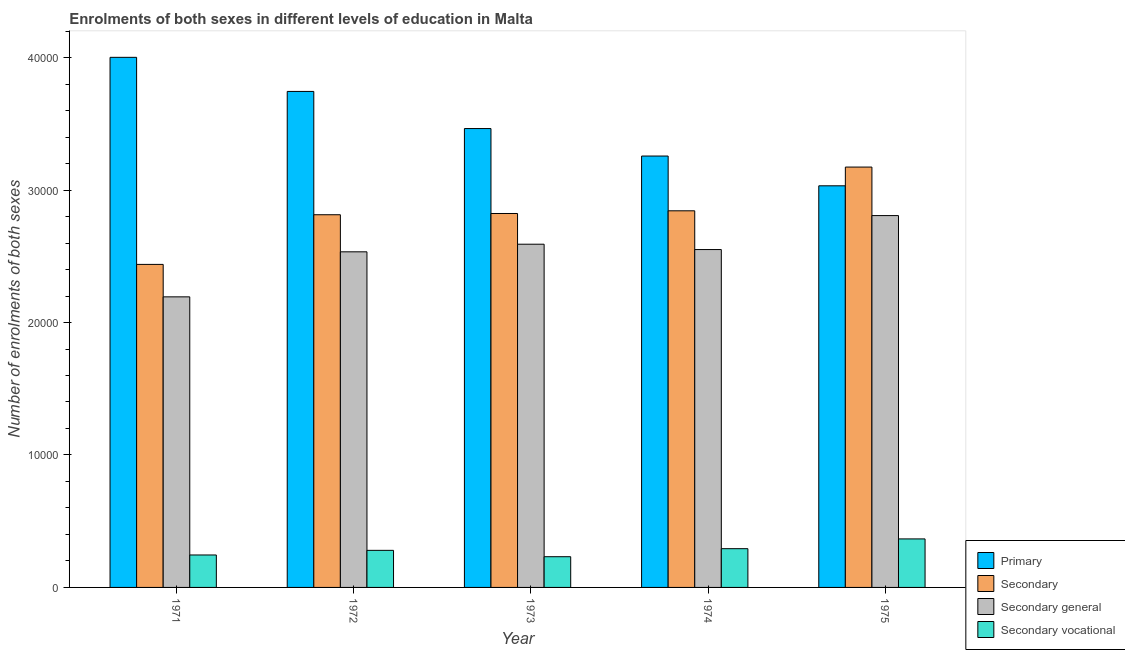How many different coloured bars are there?
Make the answer very short. 4. How many groups of bars are there?
Ensure brevity in your answer.  5. Are the number of bars on each tick of the X-axis equal?
Your answer should be compact. Yes. How many bars are there on the 4th tick from the left?
Provide a short and direct response. 4. What is the number of enrolments in primary education in 1973?
Ensure brevity in your answer.  3.46e+04. Across all years, what is the maximum number of enrolments in secondary vocational education?
Give a very brief answer. 3663. Across all years, what is the minimum number of enrolments in secondary general education?
Give a very brief answer. 2.19e+04. In which year was the number of enrolments in secondary general education maximum?
Keep it short and to the point. 1975. In which year was the number of enrolments in primary education minimum?
Ensure brevity in your answer.  1975. What is the total number of enrolments in secondary general education in the graph?
Ensure brevity in your answer.  1.27e+05. What is the difference between the number of enrolments in secondary general education in 1972 and that in 1974?
Provide a succinct answer. -171. What is the difference between the number of enrolments in secondary education in 1971 and the number of enrolments in primary education in 1973?
Offer a very short reply. -3843. What is the average number of enrolments in secondary vocational education per year?
Make the answer very short. 2831.2. What is the ratio of the number of enrolments in primary education in 1971 to that in 1974?
Provide a short and direct response. 1.23. Is the number of enrolments in secondary vocational education in 1971 less than that in 1974?
Provide a succinct answer. Yes. Is the difference between the number of enrolments in secondary education in 1974 and 1975 greater than the difference between the number of enrolments in secondary vocational education in 1974 and 1975?
Provide a succinct answer. No. What is the difference between the highest and the second highest number of enrolments in primary education?
Ensure brevity in your answer.  2574. What is the difference between the highest and the lowest number of enrolments in secondary vocational education?
Offer a very short reply. 1344. In how many years, is the number of enrolments in secondary vocational education greater than the average number of enrolments in secondary vocational education taken over all years?
Keep it short and to the point. 2. Is the sum of the number of enrolments in secondary vocational education in 1972 and 1975 greater than the maximum number of enrolments in primary education across all years?
Provide a succinct answer. Yes. Is it the case that in every year, the sum of the number of enrolments in secondary vocational education and number of enrolments in primary education is greater than the sum of number of enrolments in secondary education and number of enrolments in secondary general education?
Your response must be concise. No. What does the 3rd bar from the left in 1971 represents?
Give a very brief answer. Secondary general. What does the 2nd bar from the right in 1973 represents?
Give a very brief answer. Secondary general. Are all the bars in the graph horizontal?
Your answer should be compact. No. How many years are there in the graph?
Keep it short and to the point. 5. Are the values on the major ticks of Y-axis written in scientific E-notation?
Offer a very short reply. No. Does the graph contain any zero values?
Provide a short and direct response. No. Does the graph contain grids?
Provide a short and direct response. No. How many legend labels are there?
Your answer should be compact. 4. How are the legend labels stacked?
Provide a succinct answer. Vertical. What is the title of the graph?
Offer a terse response. Enrolments of both sexes in different levels of education in Malta. What is the label or title of the Y-axis?
Provide a succinct answer. Number of enrolments of both sexes. What is the Number of enrolments of both sexes of Primary in 1971?
Your answer should be compact. 4.00e+04. What is the Number of enrolments of both sexes of Secondary in 1971?
Your answer should be compact. 2.44e+04. What is the Number of enrolments of both sexes of Secondary general in 1971?
Your answer should be very brief. 2.19e+04. What is the Number of enrolments of both sexes in Secondary vocational in 1971?
Your answer should be compact. 2450. What is the Number of enrolments of both sexes of Primary in 1972?
Ensure brevity in your answer.  3.74e+04. What is the Number of enrolments of both sexes of Secondary in 1972?
Provide a short and direct response. 2.81e+04. What is the Number of enrolments of both sexes of Secondary general in 1972?
Your answer should be very brief. 2.53e+04. What is the Number of enrolments of both sexes of Secondary vocational in 1972?
Keep it short and to the point. 2799. What is the Number of enrolments of both sexes of Primary in 1973?
Ensure brevity in your answer.  3.46e+04. What is the Number of enrolments of both sexes of Secondary in 1973?
Your response must be concise. 2.82e+04. What is the Number of enrolments of both sexes of Secondary general in 1973?
Provide a succinct answer. 2.59e+04. What is the Number of enrolments of both sexes in Secondary vocational in 1973?
Provide a succinct answer. 2319. What is the Number of enrolments of both sexes of Primary in 1974?
Ensure brevity in your answer.  3.26e+04. What is the Number of enrolments of both sexes in Secondary in 1974?
Your answer should be compact. 2.84e+04. What is the Number of enrolments of both sexes of Secondary general in 1974?
Offer a very short reply. 2.55e+04. What is the Number of enrolments of both sexes in Secondary vocational in 1974?
Make the answer very short. 2925. What is the Number of enrolments of both sexes of Primary in 1975?
Provide a short and direct response. 3.03e+04. What is the Number of enrolments of both sexes in Secondary in 1975?
Your answer should be compact. 3.17e+04. What is the Number of enrolments of both sexes in Secondary general in 1975?
Keep it short and to the point. 2.81e+04. What is the Number of enrolments of both sexes in Secondary vocational in 1975?
Ensure brevity in your answer.  3663. Across all years, what is the maximum Number of enrolments of both sexes in Primary?
Keep it short and to the point. 4.00e+04. Across all years, what is the maximum Number of enrolments of both sexes of Secondary?
Provide a succinct answer. 3.17e+04. Across all years, what is the maximum Number of enrolments of both sexes in Secondary general?
Your response must be concise. 2.81e+04. Across all years, what is the maximum Number of enrolments of both sexes of Secondary vocational?
Make the answer very short. 3663. Across all years, what is the minimum Number of enrolments of both sexes in Primary?
Provide a short and direct response. 3.03e+04. Across all years, what is the minimum Number of enrolments of both sexes in Secondary?
Your answer should be very brief. 2.44e+04. Across all years, what is the minimum Number of enrolments of both sexes in Secondary general?
Ensure brevity in your answer.  2.19e+04. Across all years, what is the minimum Number of enrolments of both sexes in Secondary vocational?
Offer a terse response. 2319. What is the total Number of enrolments of both sexes of Primary in the graph?
Ensure brevity in your answer.  1.75e+05. What is the total Number of enrolments of both sexes in Secondary in the graph?
Your response must be concise. 1.41e+05. What is the total Number of enrolments of both sexes in Secondary general in the graph?
Make the answer very short. 1.27e+05. What is the total Number of enrolments of both sexes in Secondary vocational in the graph?
Offer a terse response. 1.42e+04. What is the difference between the Number of enrolments of both sexes of Primary in 1971 and that in 1972?
Offer a terse response. 2574. What is the difference between the Number of enrolments of both sexes of Secondary in 1971 and that in 1972?
Offer a very short reply. -3749. What is the difference between the Number of enrolments of both sexes in Secondary general in 1971 and that in 1972?
Give a very brief answer. -3400. What is the difference between the Number of enrolments of both sexes in Secondary vocational in 1971 and that in 1972?
Provide a short and direct response. -349. What is the difference between the Number of enrolments of both sexes of Primary in 1971 and that in 1973?
Keep it short and to the point. 5377. What is the difference between the Number of enrolments of both sexes in Secondary in 1971 and that in 1973?
Offer a very short reply. -3843. What is the difference between the Number of enrolments of both sexes in Secondary general in 1971 and that in 1973?
Keep it short and to the point. -3974. What is the difference between the Number of enrolments of both sexes of Secondary vocational in 1971 and that in 1973?
Offer a terse response. 131. What is the difference between the Number of enrolments of both sexes in Primary in 1971 and that in 1974?
Ensure brevity in your answer.  7452. What is the difference between the Number of enrolments of both sexes in Secondary in 1971 and that in 1974?
Ensure brevity in your answer.  -4046. What is the difference between the Number of enrolments of both sexes of Secondary general in 1971 and that in 1974?
Ensure brevity in your answer.  -3571. What is the difference between the Number of enrolments of both sexes of Secondary vocational in 1971 and that in 1974?
Your response must be concise. -475. What is the difference between the Number of enrolments of both sexes in Primary in 1971 and that in 1975?
Provide a short and direct response. 9699. What is the difference between the Number of enrolments of both sexes in Secondary in 1971 and that in 1975?
Ensure brevity in your answer.  -7348. What is the difference between the Number of enrolments of both sexes in Secondary general in 1971 and that in 1975?
Provide a succinct answer. -6135. What is the difference between the Number of enrolments of both sexes of Secondary vocational in 1971 and that in 1975?
Make the answer very short. -1213. What is the difference between the Number of enrolments of both sexes in Primary in 1972 and that in 1973?
Keep it short and to the point. 2803. What is the difference between the Number of enrolments of both sexes of Secondary in 1972 and that in 1973?
Make the answer very short. -94. What is the difference between the Number of enrolments of both sexes of Secondary general in 1972 and that in 1973?
Ensure brevity in your answer.  -574. What is the difference between the Number of enrolments of both sexes in Secondary vocational in 1972 and that in 1973?
Give a very brief answer. 480. What is the difference between the Number of enrolments of both sexes in Primary in 1972 and that in 1974?
Your answer should be compact. 4878. What is the difference between the Number of enrolments of both sexes in Secondary in 1972 and that in 1974?
Give a very brief answer. -297. What is the difference between the Number of enrolments of both sexes in Secondary general in 1972 and that in 1974?
Offer a terse response. -171. What is the difference between the Number of enrolments of both sexes of Secondary vocational in 1972 and that in 1974?
Your answer should be compact. -126. What is the difference between the Number of enrolments of both sexes in Primary in 1972 and that in 1975?
Provide a succinct answer. 7125. What is the difference between the Number of enrolments of both sexes of Secondary in 1972 and that in 1975?
Give a very brief answer. -3599. What is the difference between the Number of enrolments of both sexes of Secondary general in 1972 and that in 1975?
Your answer should be compact. -2735. What is the difference between the Number of enrolments of both sexes in Secondary vocational in 1972 and that in 1975?
Provide a short and direct response. -864. What is the difference between the Number of enrolments of both sexes of Primary in 1973 and that in 1974?
Ensure brevity in your answer.  2075. What is the difference between the Number of enrolments of both sexes in Secondary in 1973 and that in 1974?
Make the answer very short. -203. What is the difference between the Number of enrolments of both sexes in Secondary general in 1973 and that in 1974?
Your response must be concise. 403. What is the difference between the Number of enrolments of both sexes of Secondary vocational in 1973 and that in 1974?
Provide a succinct answer. -606. What is the difference between the Number of enrolments of both sexes of Primary in 1973 and that in 1975?
Your answer should be compact. 4322. What is the difference between the Number of enrolments of both sexes of Secondary in 1973 and that in 1975?
Provide a short and direct response. -3505. What is the difference between the Number of enrolments of both sexes of Secondary general in 1973 and that in 1975?
Your response must be concise. -2161. What is the difference between the Number of enrolments of both sexes in Secondary vocational in 1973 and that in 1975?
Offer a terse response. -1344. What is the difference between the Number of enrolments of both sexes in Primary in 1974 and that in 1975?
Offer a terse response. 2247. What is the difference between the Number of enrolments of both sexes in Secondary in 1974 and that in 1975?
Keep it short and to the point. -3302. What is the difference between the Number of enrolments of both sexes of Secondary general in 1974 and that in 1975?
Your response must be concise. -2564. What is the difference between the Number of enrolments of both sexes of Secondary vocational in 1974 and that in 1975?
Offer a terse response. -738. What is the difference between the Number of enrolments of both sexes of Primary in 1971 and the Number of enrolments of both sexes of Secondary in 1972?
Give a very brief answer. 1.19e+04. What is the difference between the Number of enrolments of both sexes in Primary in 1971 and the Number of enrolments of both sexes in Secondary general in 1972?
Your answer should be compact. 1.47e+04. What is the difference between the Number of enrolments of both sexes of Primary in 1971 and the Number of enrolments of both sexes of Secondary vocational in 1972?
Ensure brevity in your answer.  3.72e+04. What is the difference between the Number of enrolments of both sexes in Secondary in 1971 and the Number of enrolments of both sexes in Secondary general in 1972?
Make the answer very short. -950. What is the difference between the Number of enrolments of both sexes in Secondary in 1971 and the Number of enrolments of both sexes in Secondary vocational in 1972?
Offer a very short reply. 2.16e+04. What is the difference between the Number of enrolments of both sexes of Secondary general in 1971 and the Number of enrolments of both sexes of Secondary vocational in 1972?
Provide a succinct answer. 1.91e+04. What is the difference between the Number of enrolments of both sexes of Primary in 1971 and the Number of enrolments of both sexes of Secondary in 1973?
Give a very brief answer. 1.18e+04. What is the difference between the Number of enrolments of both sexes of Primary in 1971 and the Number of enrolments of both sexes of Secondary general in 1973?
Give a very brief answer. 1.41e+04. What is the difference between the Number of enrolments of both sexes of Primary in 1971 and the Number of enrolments of both sexes of Secondary vocational in 1973?
Ensure brevity in your answer.  3.77e+04. What is the difference between the Number of enrolments of both sexes of Secondary in 1971 and the Number of enrolments of both sexes of Secondary general in 1973?
Offer a very short reply. -1524. What is the difference between the Number of enrolments of both sexes in Secondary in 1971 and the Number of enrolments of both sexes in Secondary vocational in 1973?
Your response must be concise. 2.21e+04. What is the difference between the Number of enrolments of both sexes of Secondary general in 1971 and the Number of enrolments of both sexes of Secondary vocational in 1973?
Offer a terse response. 1.96e+04. What is the difference between the Number of enrolments of both sexes in Primary in 1971 and the Number of enrolments of both sexes in Secondary in 1974?
Ensure brevity in your answer.  1.16e+04. What is the difference between the Number of enrolments of both sexes in Primary in 1971 and the Number of enrolments of both sexes in Secondary general in 1974?
Give a very brief answer. 1.45e+04. What is the difference between the Number of enrolments of both sexes of Primary in 1971 and the Number of enrolments of both sexes of Secondary vocational in 1974?
Your answer should be compact. 3.71e+04. What is the difference between the Number of enrolments of both sexes of Secondary in 1971 and the Number of enrolments of both sexes of Secondary general in 1974?
Keep it short and to the point. -1121. What is the difference between the Number of enrolments of both sexes in Secondary in 1971 and the Number of enrolments of both sexes in Secondary vocational in 1974?
Keep it short and to the point. 2.15e+04. What is the difference between the Number of enrolments of both sexes of Secondary general in 1971 and the Number of enrolments of both sexes of Secondary vocational in 1974?
Provide a short and direct response. 1.90e+04. What is the difference between the Number of enrolments of both sexes of Primary in 1971 and the Number of enrolments of both sexes of Secondary in 1975?
Give a very brief answer. 8285. What is the difference between the Number of enrolments of both sexes in Primary in 1971 and the Number of enrolments of both sexes in Secondary general in 1975?
Provide a short and direct response. 1.19e+04. What is the difference between the Number of enrolments of both sexes of Primary in 1971 and the Number of enrolments of both sexes of Secondary vocational in 1975?
Ensure brevity in your answer.  3.64e+04. What is the difference between the Number of enrolments of both sexes in Secondary in 1971 and the Number of enrolments of both sexes in Secondary general in 1975?
Your response must be concise. -3685. What is the difference between the Number of enrolments of both sexes in Secondary in 1971 and the Number of enrolments of both sexes in Secondary vocational in 1975?
Your response must be concise. 2.07e+04. What is the difference between the Number of enrolments of both sexes of Secondary general in 1971 and the Number of enrolments of both sexes of Secondary vocational in 1975?
Provide a short and direct response. 1.83e+04. What is the difference between the Number of enrolments of both sexes of Primary in 1972 and the Number of enrolments of both sexes of Secondary in 1973?
Offer a terse response. 9216. What is the difference between the Number of enrolments of both sexes of Primary in 1972 and the Number of enrolments of both sexes of Secondary general in 1973?
Provide a short and direct response. 1.15e+04. What is the difference between the Number of enrolments of both sexes in Primary in 1972 and the Number of enrolments of both sexes in Secondary vocational in 1973?
Give a very brief answer. 3.51e+04. What is the difference between the Number of enrolments of both sexes in Secondary in 1972 and the Number of enrolments of both sexes in Secondary general in 1973?
Make the answer very short. 2225. What is the difference between the Number of enrolments of both sexes of Secondary in 1972 and the Number of enrolments of both sexes of Secondary vocational in 1973?
Your answer should be compact. 2.58e+04. What is the difference between the Number of enrolments of both sexes in Secondary general in 1972 and the Number of enrolments of both sexes in Secondary vocational in 1973?
Ensure brevity in your answer.  2.30e+04. What is the difference between the Number of enrolments of both sexes of Primary in 1972 and the Number of enrolments of both sexes of Secondary in 1974?
Offer a terse response. 9013. What is the difference between the Number of enrolments of both sexes of Primary in 1972 and the Number of enrolments of both sexes of Secondary general in 1974?
Keep it short and to the point. 1.19e+04. What is the difference between the Number of enrolments of both sexes in Primary in 1972 and the Number of enrolments of both sexes in Secondary vocational in 1974?
Provide a short and direct response. 3.45e+04. What is the difference between the Number of enrolments of both sexes in Secondary in 1972 and the Number of enrolments of both sexes in Secondary general in 1974?
Keep it short and to the point. 2628. What is the difference between the Number of enrolments of both sexes of Secondary in 1972 and the Number of enrolments of both sexes of Secondary vocational in 1974?
Keep it short and to the point. 2.52e+04. What is the difference between the Number of enrolments of both sexes in Secondary general in 1972 and the Number of enrolments of both sexes in Secondary vocational in 1974?
Your response must be concise. 2.24e+04. What is the difference between the Number of enrolments of both sexes in Primary in 1972 and the Number of enrolments of both sexes in Secondary in 1975?
Your response must be concise. 5711. What is the difference between the Number of enrolments of both sexes in Primary in 1972 and the Number of enrolments of both sexes in Secondary general in 1975?
Your answer should be very brief. 9374. What is the difference between the Number of enrolments of both sexes of Primary in 1972 and the Number of enrolments of both sexes of Secondary vocational in 1975?
Your response must be concise. 3.38e+04. What is the difference between the Number of enrolments of both sexes in Secondary in 1972 and the Number of enrolments of both sexes in Secondary general in 1975?
Provide a succinct answer. 64. What is the difference between the Number of enrolments of both sexes in Secondary in 1972 and the Number of enrolments of both sexes in Secondary vocational in 1975?
Offer a very short reply. 2.45e+04. What is the difference between the Number of enrolments of both sexes of Secondary general in 1972 and the Number of enrolments of both sexes of Secondary vocational in 1975?
Keep it short and to the point. 2.17e+04. What is the difference between the Number of enrolments of both sexes in Primary in 1973 and the Number of enrolments of both sexes in Secondary in 1974?
Provide a short and direct response. 6210. What is the difference between the Number of enrolments of both sexes in Primary in 1973 and the Number of enrolments of both sexes in Secondary general in 1974?
Ensure brevity in your answer.  9135. What is the difference between the Number of enrolments of both sexes of Primary in 1973 and the Number of enrolments of both sexes of Secondary vocational in 1974?
Keep it short and to the point. 3.17e+04. What is the difference between the Number of enrolments of both sexes of Secondary in 1973 and the Number of enrolments of both sexes of Secondary general in 1974?
Keep it short and to the point. 2722. What is the difference between the Number of enrolments of both sexes of Secondary in 1973 and the Number of enrolments of both sexes of Secondary vocational in 1974?
Give a very brief answer. 2.53e+04. What is the difference between the Number of enrolments of both sexes in Secondary general in 1973 and the Number of enrolments of both sexes in Secondary vocational in 1974?
Make the answer very short. 2.30e+04. What is the difference between the Number of enrolments of both sexes of Primary in 1973 and the Number of enrolments of both sexes of Secondary in 1975?
Your answer should be very brief. 2908. What is the difference between the Number of enrolments of both sexes in Primary in 1973 and the Number of enrolments of both sexes in Secondary general in 1975?
Give a very brief answer. 6571. What is the difference between the Number of enrolments of both sexes of Primary in 1973 and the Number of enrolments of both sexes of Secondary vocational in 1975?
Offer a very short reply. 3.10e+04. What is the difference between the Number of enrolments of both sexes of Secondary in 1973 and the Number of enrolments of both sexes of Secondary general in 1975?
Ensure brevity in your answer.  158. What is the difference between the Number of enrolments of both sexes of Secondary in 1973 and the Number of enrolments of both sexes of Secondary vocational in 1975?
Your answer should be compact. 2.46e+04. What is the difference between the Number of enrolments of both sexes in Secondary general in 1973 and the Number of enrolments of both sexes in Secondary vocational in 1975?
Provide a short and direct response. 2.22e+04. What is the difference between the Number of enrolments of both sexes of Primary in 1974 and the Number of enrolments of both sexes of Secondary in 1975?
Make the answer very short. 833. What is the difference between the Number of enrolments of both sexes in Primary in 1974 and the Number of enrolments of both sexes in Secondary general in 1975?
Keep it short and to the point. 4496. What is the difference between the Number of enrolments of both sexes of Primary in 1974 and the Number of enrolments of both sexes of Secondary vocational in 1975?
Your answer should be very brief. 2.89e+04. What is the difference between the Number of enrolments of both sexes in Secondary in 1974 and the Number of enrolments of both sexes in Secondary general in 1975?
Give a very brief answer. 361. What is the difference between the Number of enrolments of both sexes of Secondary in 1974 and the Number of enrolments of both sexes of Secondary vocational in 1975?
Offer a very short reply. 2.48e+04. What is the difference between the Number of enrolments of both sexes in Secondary general in 1974 and the Number of enrolments of both sexes in Secondary vocational in 1975?
Keep it short and to the point. 2.18e+04. What is the average Number of enrolments of both sexes in Primary per year?
Provide a succinct answer. 3.50e+04. What is the average Number of enrolments of both sexes in Secondary per year?
Provide a succinct answer. 2.82e+04. What is the average Number of enrolments of both sexes in Secondary general per year?
Your response must be concise. 2.54e+04. What is the average Number of enrolments of both sexes in Secondary vocational per year?
Offer a very short reply. 2831.2. In the year 1971, what is the difference between the Number of enrolments of both sexes of Primary and Number of enrolments of both sexes of Secondary?
Ensure brevity in your answer.  1.56e+04. In the year 1971, what is the difference between the Number of enrolments of both sexes in Primary and Number of enrolments of both sexes in Secondary general?
Provide a short and direct response. 1.81e+04. In the year 1971, what is the difference between the Number of enrolments of both sexes of Primary and Number of enrolments of both sexes of Secondary vocational?
Keep it short and to the point. 3.76e+04. In the year 1971, what is the difference between the Number of enrolments of both sexes of Secondary and Number of enrolments of both sexes of Secondary general?
Your answer should be compact. 2450. In the year 1971, what is the difference between the Number of enrolments of both sexes in Secondary and Number of enrolments of both sexes in Secondary vocational?
Offer a terse response. 2.19e+04. In the year 1971, what is the difference between the Number of enrolments of both sexes in Secondary general and Number of enrolments of both sexes in Secondary vocational?
Provide a succinct answer. 1.95e+04. In the year 1972, what is the difference between the Number of enrolments of both sexes of Primary and Number of enrolments of both sexes of Secondary?
Your response must be concise. 9310. In the year 1972, what is the difference between the Number of enrolments of both sexes of Primary and Number of enrolments of both sexes of Secondary general?
Your response must be concise. 1.21e+04. In the year 1972, what is the difference between the Number of enrolments of both sexes of Primary and Number of enrolments of both sexes of Secondary vocational?
Keep it short and to the point. 3.46e+04. In the year 1972, what is the difference between the Number of enrolments of both sexes of Secondary and Number of enrolments of both sexes of Secondary general?
Your answer should be very brief. 2799. In the year 1972, what is the difference between the Number of enrolments of both sexes of Secondary and Number of enrolments of both sexes of Secondary vocational?
Provide a short and direct response. 2.53e+04. In the year 1972, what is the difference between the Number of enrolments of both sexes in Secondary general and Number of enrolments of both sexes in Secondary vocational?
Offer a very short reply. 2.25e+04. In the year 1973, what is the difference between the Number of enrolments of both sexes of Primary and Number of enrolments of both sexes of Secondary?
Provide a short and direct response. 6413. In the year 1973, what is the difference between the Number of enrolments of both sexes of Primary and Number of enrolments of both sexes of Secondary general?
Your response must be concise. 8732. In the year 1973, what is the difference between the Number of enrolments of both sexes of Primary and Number of enrolments of both sexes of Secondary vocational?
Make the answer very short. 3.23e+04. In the year 1973, what is the difference between the Number of enrolments of both sexes in Secondary and Number of enrolments of both sexes in Secondary general?
Offer a very short reply. 2319. In the year 1973, what is the difference between the Number of enrolments of both sexes of Secondary and Number of enrolments of both sexes of Secondary vocational?
Keep it short and to the point. 2.59e+04. In the year 1973, what is the difference between the Number of enrolments of both sexes of Secondary general and Number of enrolments of both sexes of Secondary vocational?
Ensure brevity in your answer.  2.36e+04. In the year 1974, what is the difference between the Number of enrolments of both sexes in Primary and Number of enrolments of both sexes in Secondary?
Provide a succinct answer. 4135. In the year 1974, what is the difference between the Number of enrolments of both sexes in Primary and Number of enrolments of both sexes in Secondary general?
Ensure brevity in your answer.  7060. In the year 1974, what is the difference between the Number of enrolments of both sexes in Primary and Number of enrolments of both sexes in Secondary vocational?
Your response must be concise. 2.96e+04. In the year 1974, what is the difference between the Number of enrolments of both sexes in Secondary and Number of enrolments of both sexes in Secondary general?
Ensure brevity in your answer.  2925. In the year 1974, what is the difference between the Number of enrolments of both sexes in Secondary and Number of enrolments of both sexes in Secondary vocational?
Offer a very short reply. 2.55e+04. In the year 1974, what is the difference between the Number of enrolments of both sexes in Secondary general and Number of enrolments of both sexes in Secondary vocational?
Your answer should be very brief. 2.26e+04. In the year 1975, what is the difference between the Number of enrolments of both sexes in Primary and Number of enrolments of both sexes in Secondary?
Provide a short and direct response. -1414. In the year 1975, what is the difference between the Number of enrolments of both sexes of Primary and Number of enrolments of both sexes of Secondary general?
Ensure brevity in your answer.  2249. In the year 1975, what is the difference between the Number of enrolments of both sexes of Primary and Number of enrolments of both sexes of Secondary vocational?
Offer a terse response. 2.67e+04. In the year 1975, what is the difference between the Number of enrolments of both sexes in Secondary and Number of enrolments of both sexes in Secondary general?
Offer a very short reply. 3663. In the year 1975, what is the difference between the Number of enrolments of both sexes in Secondary and Number of enrolments of both sexes in Secondary vocational?
Offer a very short reply. 2.81e+04. In the year 1975, what is the difference between the Number of enrolments of both sexes of Secondary general and Number of enrolments of both sexes of Secondary vocational?
Provide a short and direct response. 2.44e+04. What is the ratio of the Number of enrolments of both sexes of Primary in 1971 to that in 1972?
Your answer should be compact. 1.07. What is the ratio of the Number of enrolments of both sexes of Secondary in 1971 to that in 1972?
Offer a terse response. 0.87. What is the ratio of the Number of enrolments of both sexes of Secondary general in 1971 to that in 1972?
Offer a very short reply. 0.87. What is the ratio of the Number of enrolments of both sexes of Secondary vocational in 1971 to that in 1972?
Offer a terse response. 0.88. What is the ratio of the Number of enrolments of both sexes in Primary in 1971 to that in 1973?
Your response must be concise. 1.16. What is the ratio of the Number of enrolments of both sexes in Secondary in 1971 to that in 1973?
Make the answer very short. 0.86. What is the ratio of the Number of enrolments of both sexes in Secondary general in 1971 to that in 1973?
Offer a very short reply. 0.85. What is the ratio of the Number of enrolments of both sexes of Secondary vocational in 1971 to that in 1973?
Ensure brevity in your answer.  1.06. What is the ratio of the Number of enrolments of both sexes in Primary in 1971 to that in 1974?
Make the answer very short. 1.23. What is the ratio of the Number of enrolments of both sexes of Secondary in 1971 to that in 1974?
Offer a very short reply. 0.86. What is the ratio of the Number of enrolments of both sexes of Secondary general in 1971 to that in 1974?
Offer a very short reply. 0.86. What is the ratio of the Number of enrolments of both sexes in Secondary vocational in 1971 to that in 1974?
Your answer should be compact. 0.84. What is the ratio of the Number of enrolments of both sexes of Primary in 1971 to that in 1975?
Ensure brevity in your answer.  1.32. What is the ratio of the Number of enrolments of both sexes in Secondary in 1971 to that in 1975?
Keep it short and to the point. 0.77. What is the ratio of the Number of enrolments of both sexes of Secondary general in 1971 to that in 1975?
Offer a terse response. 0.78. What is the ratio of the Number of enrolments of both sexes of Secondary vocational in 1971 to that in 1975?
Your answer should be very brief. 0.67. What is the ratio of the Number of enrolments of both sexes in Primary in 1972 to that in 1973?
Make the answer very short. 1.08. What is the ratio of the Number of enrolments of both sexes of Secondary in 1972 to that in 1973?
Your response must be concise. 1. What is the ratio of the Number of enrolments of both sexes in Secondary general in 1972 to that in 1973?
Ensure brevity in your answer.  0.98. What is the ratio of the Number of enrolments of both sexes in Secondary vocational in 1972 to that in 1973?
Your answer should be very brief. 1.21. What is the ratio of the Number of enrolments of both sexes in Primary in 1972 to that in 1974?
Offer a terse response. 1.15. What is the ratio of the Number of enrolments of both sexes of Secondary general in 1972 to that in 1974?
Provide a succinct answer. 0.99. What is the ratio of the Number of enrolments of both sexes in Secondary vocational in 1972 to that in 1974?
Give a very brief answer. 0.96. What is the ratio of the Number of enrolments of both sexes of Primary in 1972 to that in 1975?
Make the answer very short. 1.24. What is the ratio of the Number of enrolments of both sexes of Secondary in 1972 to that in 1975?
Ensure brevity in your answer.  0.89. What is the ratio of the Number of enrolments of both sexes of Secondary general in 1972 to that in 1975?
Offer a terse response. 0.9. What is the ratio of the Number of enrolments of both sexes of Secondary vocational in 1972 to that in 1975?
Make the answer very short. 0.76. What is the ratio of the Number of enrolments of both sexes in Primary in 1973 to that in 1974?
Give a very brief answer. 1.06. What is the ratio of the Number of enrolments of both sexes of Secondary in 1973 to that in 1974?
Offer a very short reply. 0.99. What is the ratio of the Number of enrolments of both sexes of Secondary general in 1973 to that in 1974?
Keep it short and to the point. 1.02. What is the ratio of the Number of enrolments of both sexes of Secondary vocational in 1973 to that in 1974?
Offer a very short reply. 0.79. What is the ratio of the Number of enrolments of both sexes in Primary in 1973 to that in 1975?
Ensure brevity in your answer.  1.14. What is the ratio of the Number of enrolments of both sexes in Secondary in 1973 to that in 1975?
Your response must be concise. 0.89. What is the ratio of the Number of enrolments of both sexes of Secondary general in 1973 to that in 1975?
Offer a terse response. 0.92. What is the ratio of the Number of enrolments of both sexes of Secondary vocational in 1973 to that in 1975?
Offer a very short reply. 0.63. What is the ratio of the Number of enrolments of both sexes in Primary in 1974 to that in 1975?
Give a very brief answer. 1.07. What is the ratio of the Number of enrolments of both sexes in Secondary in 1974 to that in 1975?
Keep it short and to the point. 0.9. What is the ratio of the Number of enrolments of both sexes of Secondary general in 1974 to that in 1975?
Your answer should be compact. 0.91. What is the ratio of the Number of enrolments of both sexes in Secondary vocational in 1974 to that in 1975?
Keep it short and to the point. 0.8. What is the difference between the highest and the second highest Number of enrolments of both sexes of Primary?
Provide a short and direct response. 2574. What is the difference between the highest and the second highest Number of enrolments of both sexes in Secondary?
Ensure brevity in your answer.  3302. What is the difference between the highest and the second highest Number of enrolments of both sexes in Secondary general?
Your answer should be very brief. 2161. What is the difference between the highest and the second highest Number of enrolments of both sexes in Secondary vocational?
Offer a very short reply. 738. What is the difference between the highest and the lowest Number of enrolments of both sexes of Primary?
Provide a short and direct response. 9699. What is the difference between the highest and the lowest Number of enrolments of both sexes in Secondary?
Provide a succinct answer. 7348. What is the difference between the highest and the lowest Number of enrolments of both sexes of Secondary general?
Provide a succinct answer. 6135. What is the difference between the highest and the lowest Number of enrolments of both sexes in Secondary vocational?
Ensure brevity in your answer.  1344. 